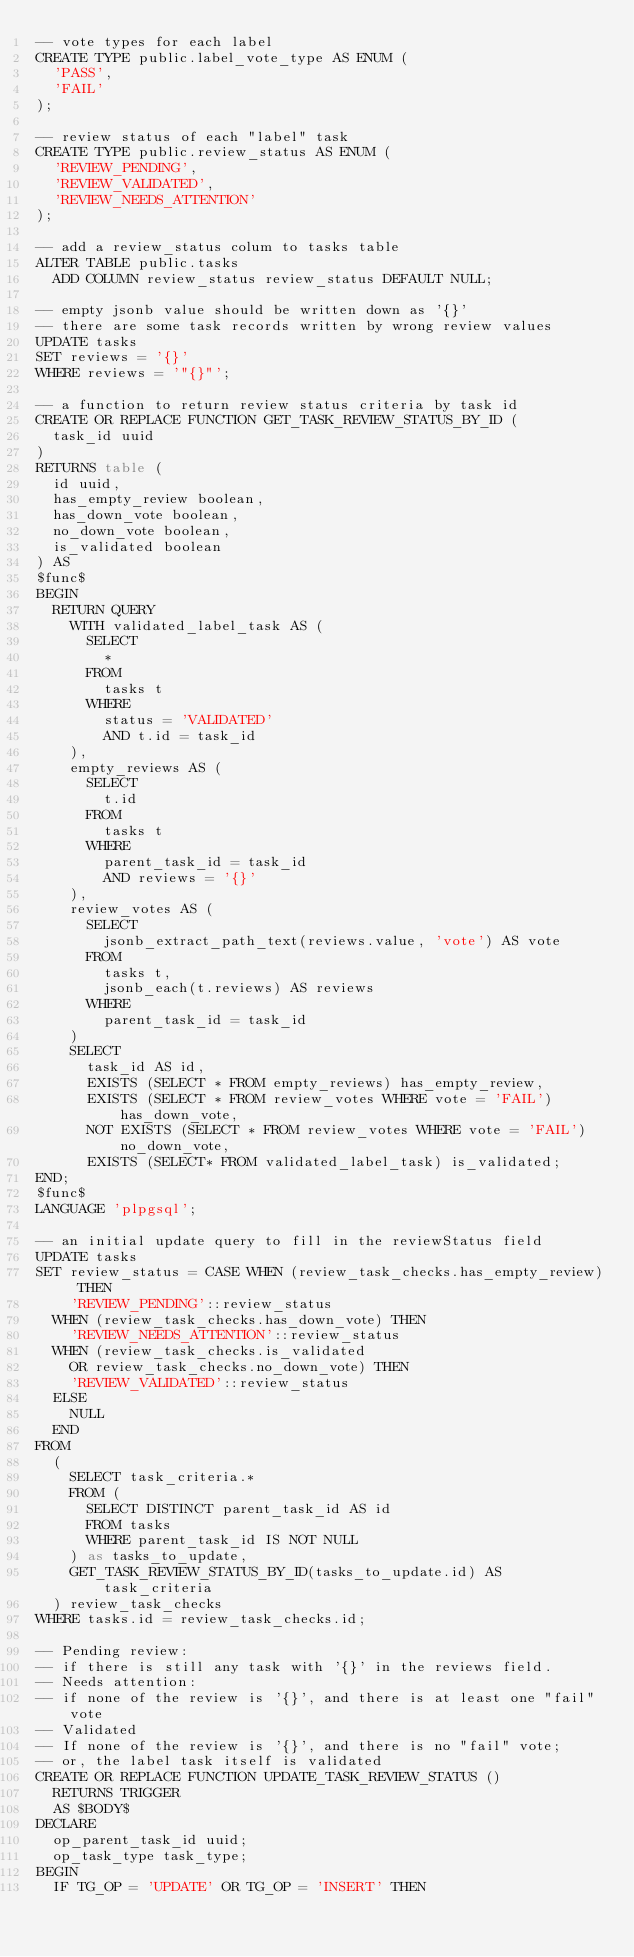Convert code to text. <code><loc_0><loc_0><loc_500><loc_500><_SQL_>-- vote types for each label
CREATE TYPE public.label_vote_type AS ENUM (
  'PASS',
  'FAIL'
);

-- review status of each "label" task
CREATE TYPE public.review_status AS ENUM (
  'REVIEW_PENDING',
  'REVIEW_VALIDATED',
  'REVIEW_NEEDS_ATTENTION'
);

-- add a review_status colum to tasks table
ALTER TABLE public.tasks
  ADD COLUMN review_status review_status DEFAULT NULL;

-- empty jsonb value should be written down as '{}'
-- there are some task records written by wrong review values
UPDATE tasks
SET reviews = '{}'
WHERE reviews = '"{}"';

-- a function to return review status criteria by task id
CREATE OR REPLACE FUNCTION GET_TASK_REVIEW_STATUS_BY_ID (
  task_id uuid
)
RETURNS table (
  id uuid,
  has_empty_review boolean,
  has_down_vote boolean,
  no_down_vote boolean,
  is_validated boolean
) AS
$func$
BEGIN
  RETURN QUERY
    WITH validated_label_task AS (
      SELECT
        *
      FROM
        tasks t
      WHERE
        status = 'VALIDATED'
        AND t.id = task_id
    ),
    empty_reviews AS (
      SELECT
        t.id
      FROM
        tasks t
      WHERE
        parent_task_id = task_id
        AND reviews = '{}'
    ),
    review_votes AS (
      SELECT
        jsonb_extract_path_text(reviews.value, 'vote') AS vote
      FROM
        tasks t,
        jsonb_each(t.reviews) AS reviews
      WHERE
        parent_task_id = task_id
    )
    SELECT
      task_id AS id,
      EXISTS (SELECT * FROM empty_reviews) has_empty_review,
      EXISTS (SELECT * FROM review_votes WHERE vote = 'FAIL') has_down_vote,
      NOT EXISTS (SELECT * FROM review_votes WHERE vote = 'FAIL') no_down_vote,
      EXISTS (SELECT* FROM validated_label_task) is_validated;
END;
$func$
LANGUAGE 'plpgsql';

-- an initial update query to fill in the reviewStatus field
UPDATE tasks
SET review_status = CASE WHEN (review_task_checks.has_empty_review) THEN
    'REVIEW_PENDING'::review_status
  WHEN (review_task_checks.has_down_vote) THEN
    'REVIEW_NEEDS_ATTENTION'::review_status
  WHEN (review_task_checks.is_validated
    OR review_task_checks.no_down_vote) THEN
    'REVIEW_VALIDATED'::review_status
  ELSE
    NULL
  END
FROM
  (
    SELECT task_criteria.*
    FROM (
      SELECT DISTINCT parent_task_id AS id
      FROM tasks
      WHERE parent_task_id IS NOT NULL
    ) as tasks_to_update,
    GET_TASK_REVIEW_STATUS_BY_ID(tasks_to_update.id) AS task_criteria
  ) review_task_checks
WHERE tasks.id = review_task_checks.id;

-- Pending review:
-- if there is still any task with '{}' in the reviews field.
-- Needs attention:
-- if none of the review is '{}', and there is at least one "fail" vote
-- Validated
-- If none of the review is '{}', and there is no "fail" vote;
-- or, the label task itself is validated
CREATE OR REPLACE FUNCTION UPDATE_TASK_REVIEW_STATUS ()
  RETURNS TRIGGER
  AS $BODY$
DECLARE
  op_parent_task_id uuid;
  op_task_type task_type;
BEGIN
  IF TG_OP = 'UPDATE' OR TG_OP = 'INSERT' THEN</code> 